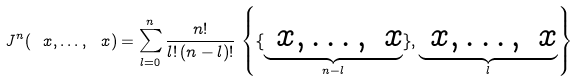Convert formula to latex. <formula><loc_0><loc_0><loc_500><loc_500>J ^ { n } ( \ x , \dots , \ x ) = \sum _ { l = 0 } ^ { n } \frac { n ! } { l ! \, ( n - l ) ! } \, \left \{ \{ \underbrace { \ x , \dots , \ x } _ { n - l } \} , \underbrace { \ x , \dots , \ x } _ { l } \right \}</formula> 